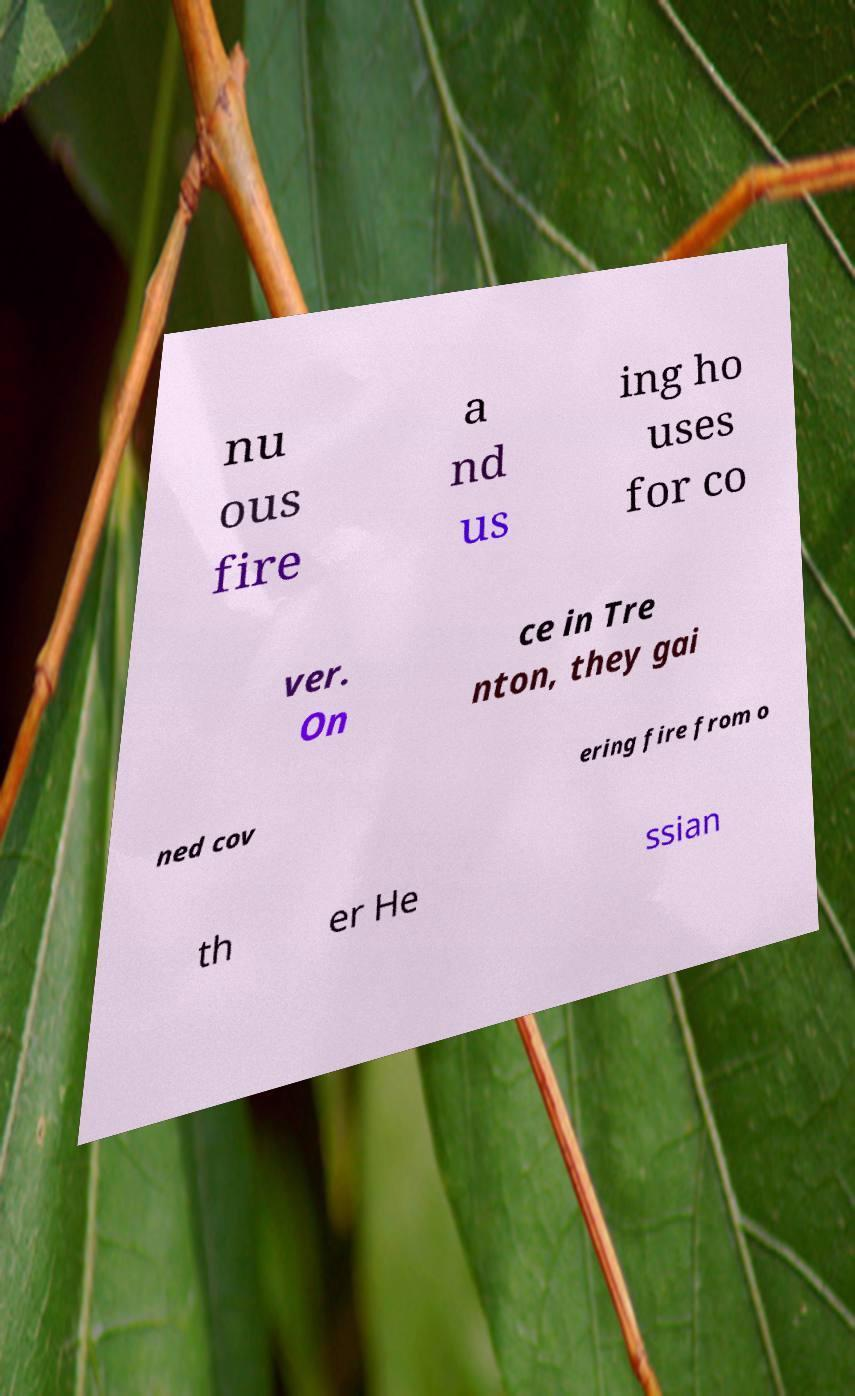Please read and relay the text visible in this image. What does it say? nu ous fire a nd us ing ho uses for co ver. On ce in Tre nton, they gai ned cov ering fire from o th er He ssian 